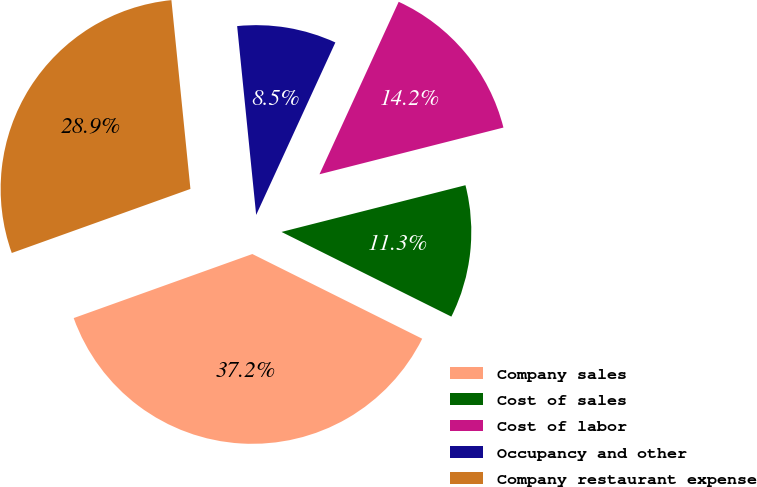Convert chart to OTSL. <chart><loc_0><loc_0><loc_500><loc_500><pie_chart><fcel>Company sales<fcel>Cost of sales<fcel>Cost of labor<fcel>Occupancy and other<fcel>Company restaurant expense<nl><fcel>37.16%<fcel>11.32%<fcel>14.19%<fcel>8.45%<fcel>28.88%<nl></chart> 